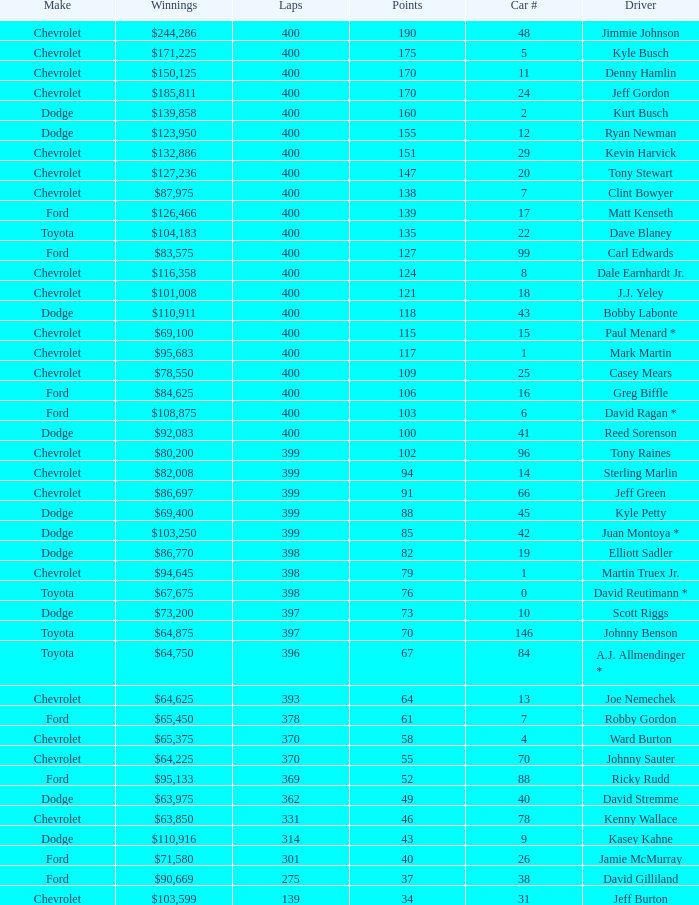What were the winnings for the Chevrolet with a number larger than 29 and scored 102 points? $80,200. 